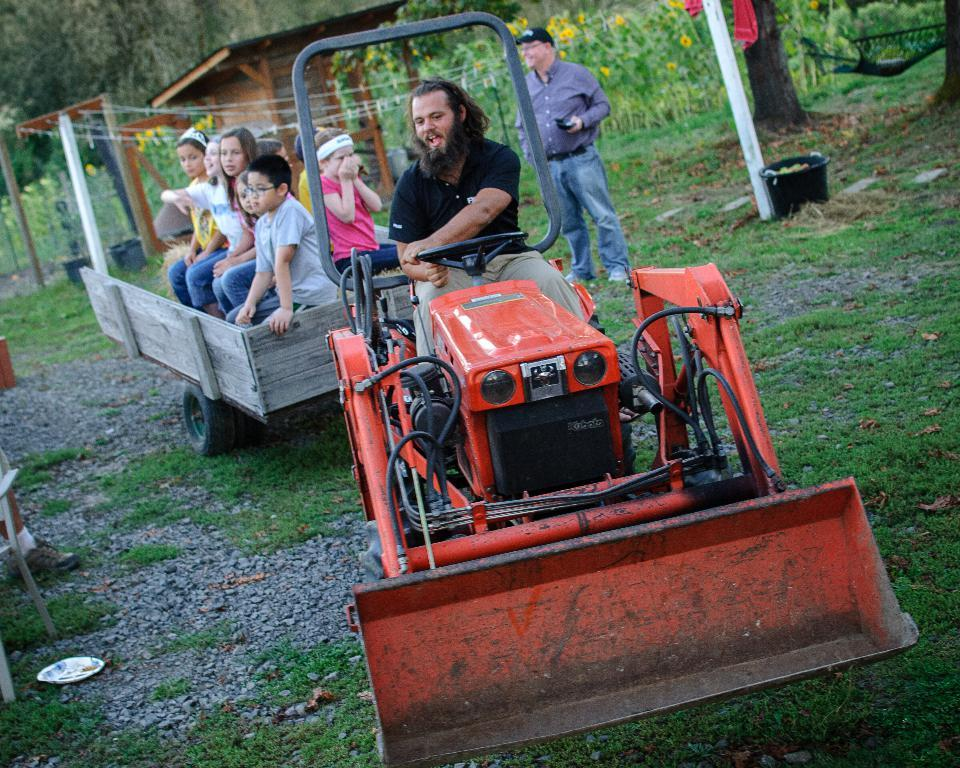What are the people in the image doing? The people in the image are sitting on a vehicle. What is the man in the image doing? There is a man standing in the image. What type of environment is visible in the image? There is grass visible in the image, and there are trees, plants, and flowers in the background. Where is the nest of the quartz located in the image? There is no nest or quartz present in the image. What type of game are the people playing in the image? There is no game being played in the image; the people are simply sitting on a vehicle. 